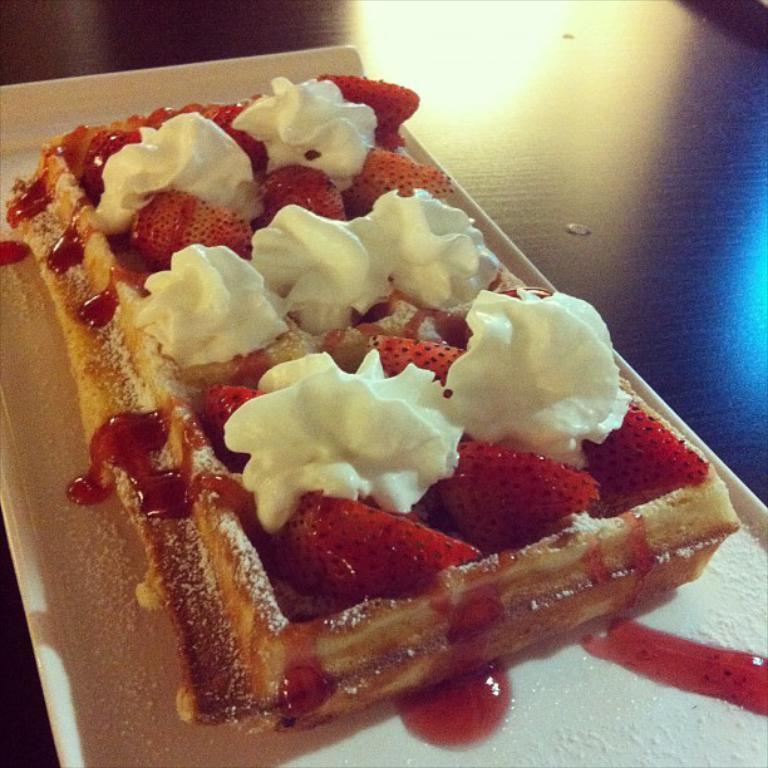What object is present in the image that typically holds food? There is a plate in the image. What is on the plate? The plate contains food. How many children are sitting on the plate in the image? There are no children present in the image; it only contains a plate with food. 